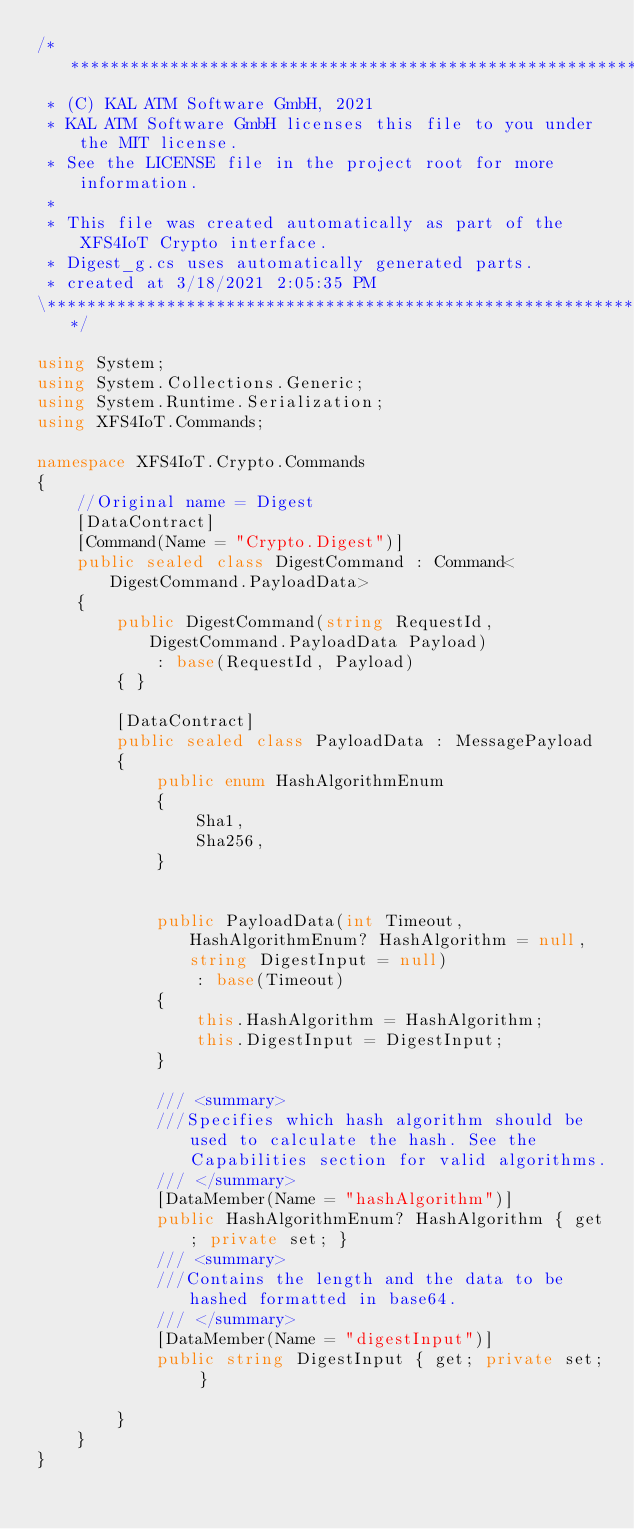Convert code to text. <code><loc_0><loc_0><loc_500><loc_500><_C#_>/***********************************************************************************************\
 * (C) KAL ATM Software GmbH, 2021
 * KAL ATM Software GmbH licenses this file to you under the MIT license.
 * See the LICENSE file in the project root for more information.
 *
 * This file was created automatically as part of the XFS4IoT Crypto interface.
 * Digest_g.cs uses automatically generated parts. 
 * created at 3/18/2021 2:05:35 PM
\***********************************************************************************************/

using System;
using System.Collections.Generic;
using System.Runtime.Serialization;
using XFS4IoT.Commands;

namespace XFS4IoT.Crypto.Commands
{
    //Original name = Digest
    [DataContract]
    [Command(Name = "Crypto.Digest")]
    public sealed class DigestCommand : Command<DigestCommand.PayloadData>
    {
        public DigestCommand(string RequestId, DigestCommand.PayloadData Payload)
            : base(RequestId, Payload)
        { }

        [DataContract]
        public sealed class PayloadData : MessagePayload
        {
            public enum HashAlgorithmEnum
            {
                Sha1,
                Sha256,
            }


            public PayloadData(int Timeout, HashAlgorithmEnum? HashAlgorithm = null, string DigestInput = null)
                : base(Timeout)
            {
                this.HashAlgorithm = HashAlgorithm;
                this.DigestInput = DigestInput;
            }

            /// <summary>
            ///Specifies which hash algorithm should be used to calculate the hash. See the Capabilities section for valid algorithms.
            /// </summary>
            [DataMember(Name = "hashAlgorithm")] 
            public HashAlgorithmEnum? HashAlgorithm { get; private set; }
            /// <summary>
            ///Contains the length and the data to be hashed formatted in base64.
            /// </summary>
            [DataMember(Name = "digestInput")] 
            public string DigestInput { get; private set; }

        }
    }
}
</code> 